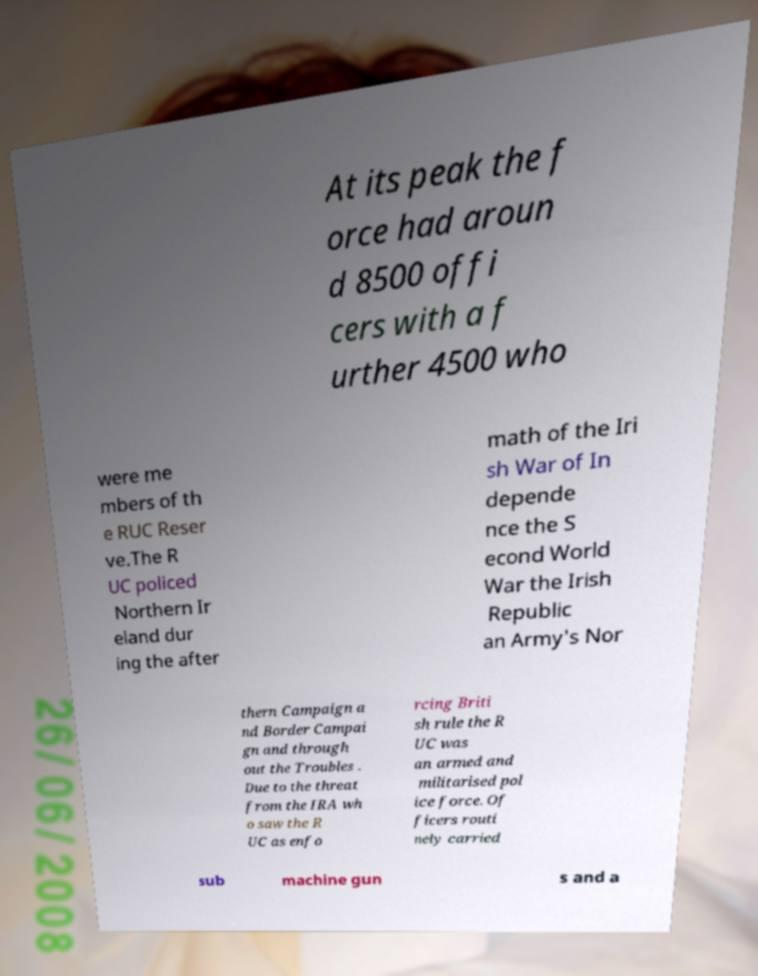Can you read and provide the text displayed in the image?This photo seems to have some interesting text. Can you extract and type it out for me? At its peak the f orce had aroun d 8500 offi cers with a f urther 4500 who were me mbers of th e RUC Reser ve.The R UC policed Northern Ir eland dur ing the after math of the Iri sh War of In depende nce the S econd World War the Irish Republic an Army's Nor thern Campaign a nd Border Campai gn and through out the Troubles . Due to the threat from the IRA wh o saw the R UC as enfo rcing Briti sh rule the R UC was an armed and militarised pol ice force. Of ficers routi nely carried sub machine gun s and a 